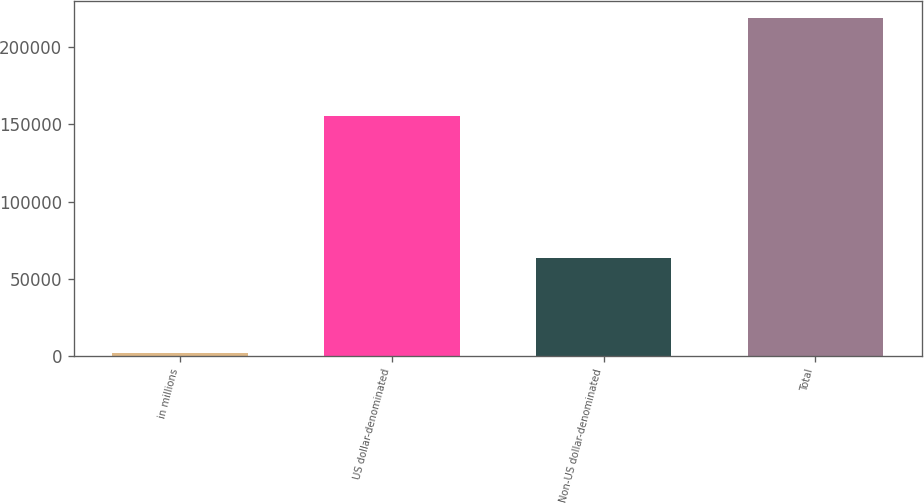Convert chart. <chart><loc_0><loc_0><loc_500><loc_500><bar_chart><fcel>in millions<fcel>US dollar-denominated<fcel>Non-US dollar-denominated<fcel>Total<nl><fcel>2017<fcel>155020<fcel>63528<fcel>218548<nl></chart> 